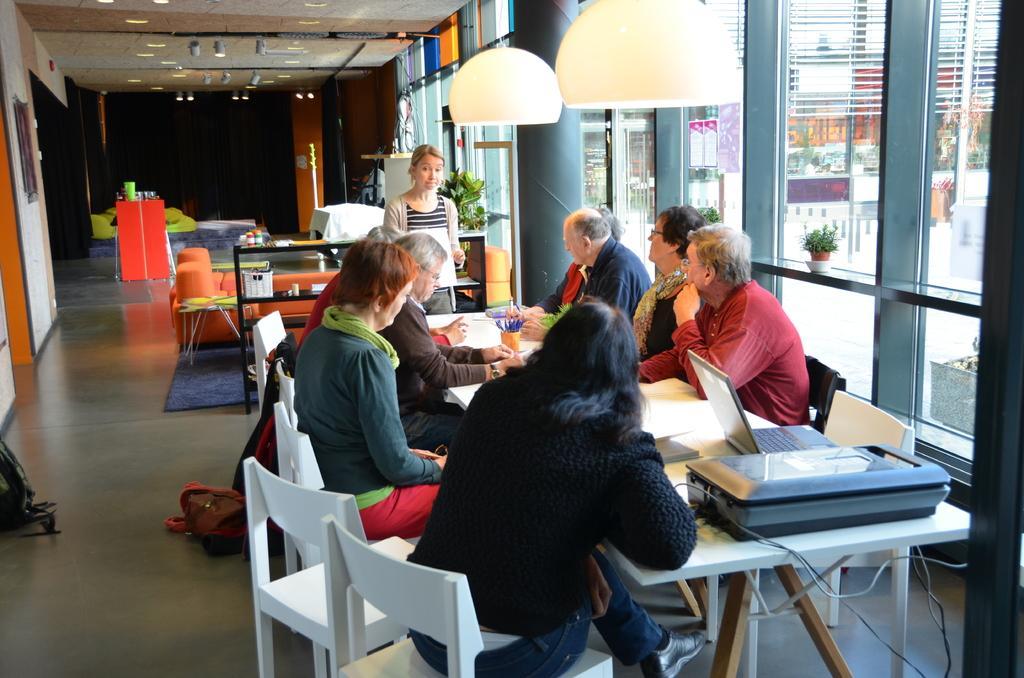How would you summarize this image in a sentence or two? there are so many people sitting around a table and then there is a laptop and printer and the lights from the top. 